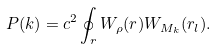<formula> <loc_0><loc_0><loc_500><loc_500>P ( k ) = c ^ { 2 } \oint _ { r } W _ { \rho } ( r ) W _ { M _ { k } } ( r _ { l } ) .</formula> 